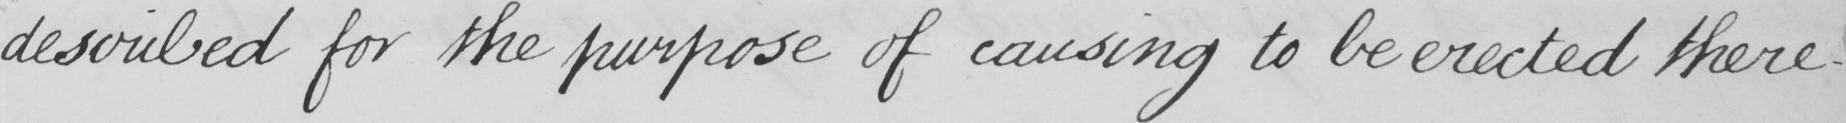Please provide the text content of this handwritten line. described for the purpose of causing to be erected there- 